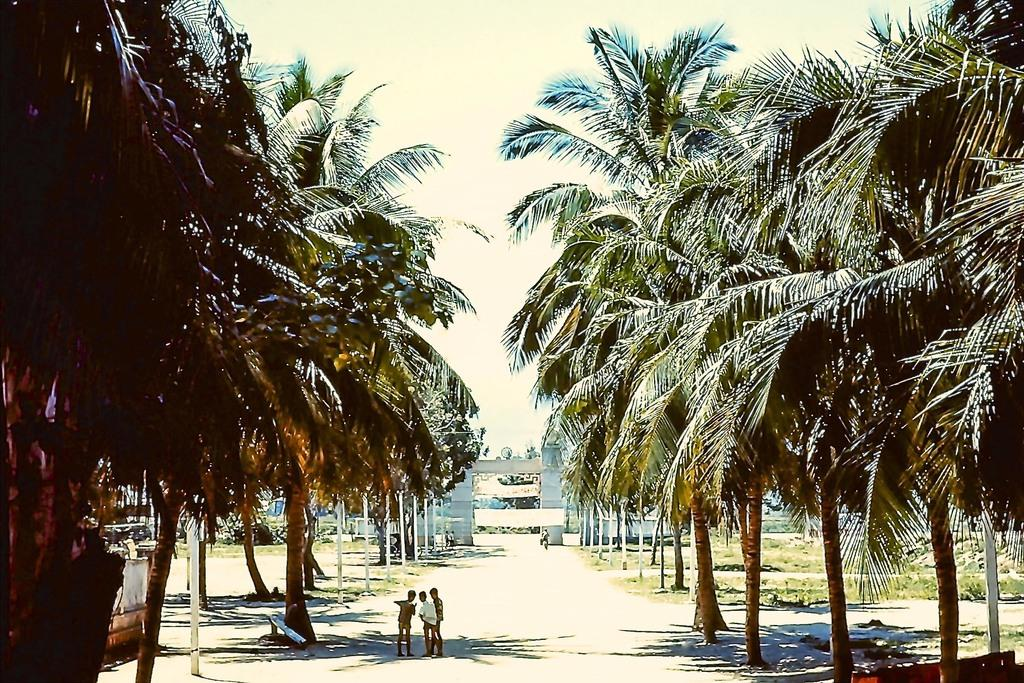What type of vegetation is present in the image? There are trees in the image. What else can be seen in the image besides trees? There are people standing in the image, as well as an arch with a banner. What is the ground covered with in the image? The ground is covered with grass in the image. How would you describe the sky in the image? The sky is cloudy in the image. What type of anger is being expressed by the trees in the image? There is no anger expressed by the trees in the image, as trees do not have emotions. Can you see any sticks being used by the people in the image? There is no mention of sticks in the image, so we cannot determine if they are present or not. 